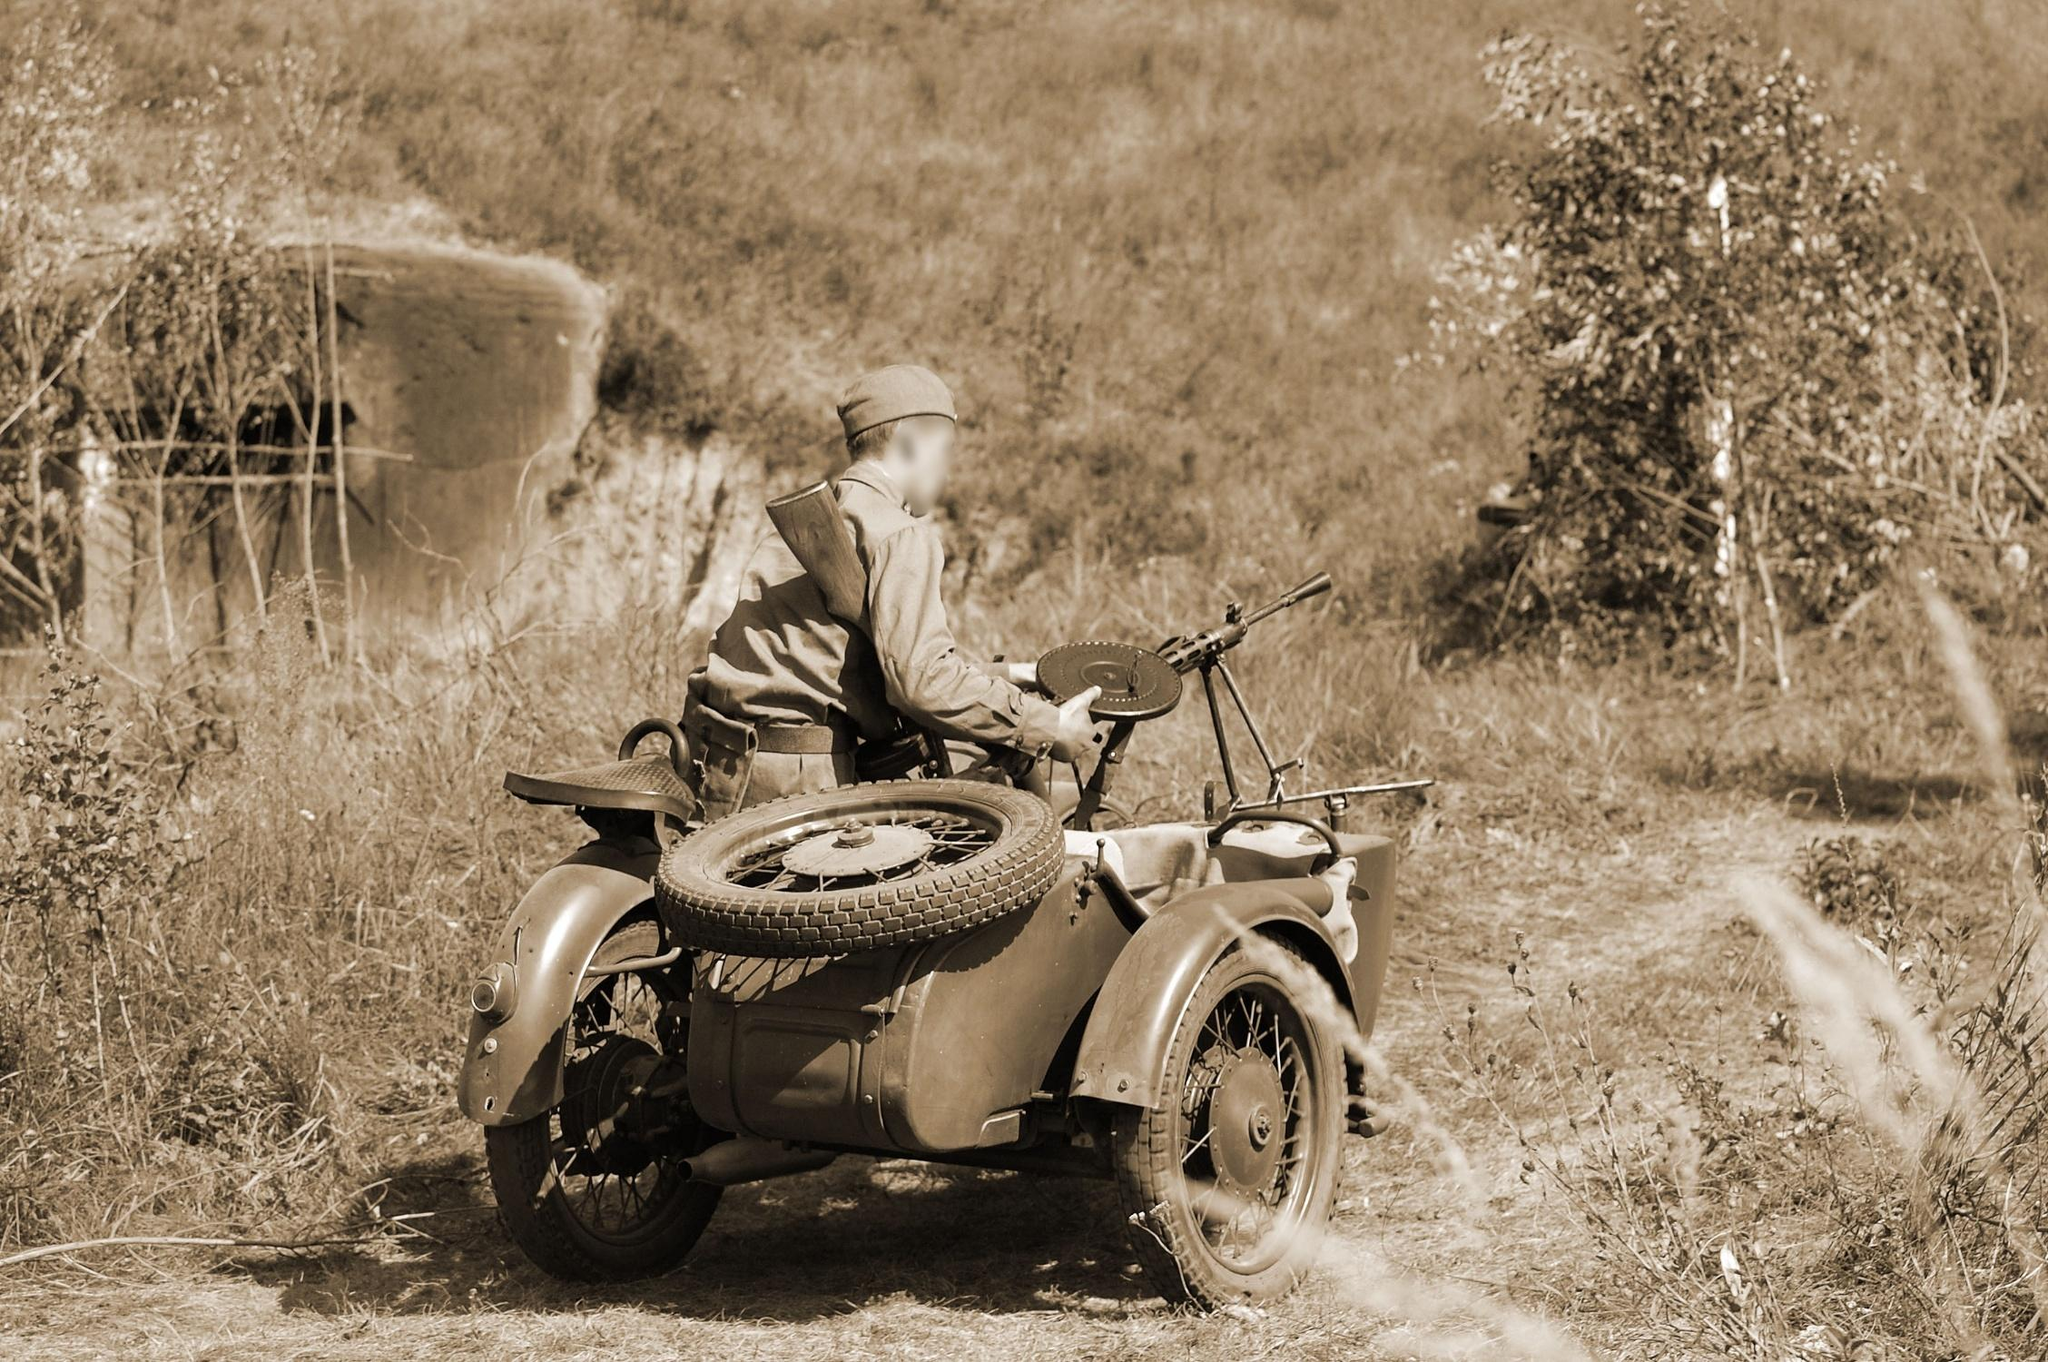Can you describe the historical period that this motorcycle might belong to? This motorcycle, including its design and the sidecar attached, likely dates back to the early to mid-20th century, a period when such models were commonly used in military operations during World War II. The presence of the sidecar was particularly useful for adding carrying capacity or a passenger, often seen in military contexts of the 1940s. 